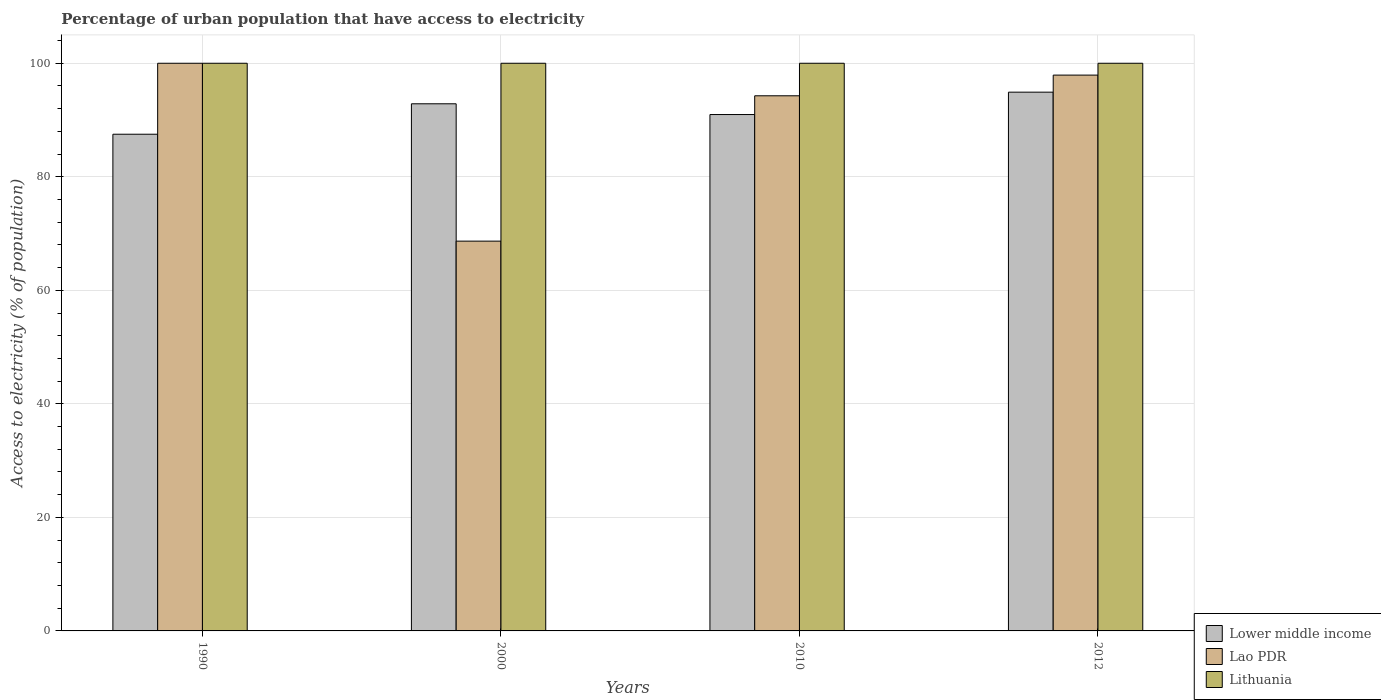How many groups of bars are there?
Offer a very short reply. 4. Are the number of bars per tick equal to the number of legend labels?
Make the answer very short. Yes. Are the number of bars on each tick of the X-axis equal?
Your answer should be compact. Yes. How many bars are there on the 3rd tick from the left?
Your answer should be compact. 3. How many bars are there on the 4th tick from the right?
Offer a terse response. 3. What is the percentage of urban population that have access to electricity in Lao PDR in 2012?
Offer a very short reply. 97.91. Across all years, what is the maximum percentage of urban population that have access to electricity in Lower middle income?
Provide a succinct answer. 94.91. Across all years, what is the minimum percentage of urban population that have access to electricity in Lao PDR?
Provide a short and direct response. 68.67. In which year was the percentage of urban population that have access to electricity in Lithuania maximum?
Offer a terse response. 1990. In which year was the percentage of urban population that have access to electricity in Lithuania minimum?
Provide a short and direct response. 1990. What is the total percentage of urban population that have access to electricity in Lao PDR in the graph?
Provide a succinct answer. 360.85. What is the difference between the percentage of urban population that have access to electricity in Lower middle income in 2000 and that in 2012?
Make the answer very short. -2.05. What is the difference between the percentage of urban population that have access to electricity in Lithuania in 2012 and the percentage of urban population that have access to electricity in Lao PDR in 1990?
Your answer should be very brief. 0. In the year 2000, what is the difference between the percentage of urban population that have access to electricity in Lao PDR and percentage of urban population that have access to electricity in Lower middle income?
Offer a terse response. -24.19. Is the percentage of urban population that have access to electricity in Lower middle income in 2000 less than that in 2010?
Offer a very short reply. No. What is the difference between the highest and the second highest percentage of urban population that have access to electricity in Lao PDR?
Provide a succinct answer. 2.09. What is the difference between the highest and the lowest percentage of urban population that have access to electricity in Lao PDR?
Your response must be concise. 31.33. Is the sum of the percentage of urban population that have access to electricity in Lithuania in 2010 and 2012 greater than the maximum percentage of urban population that have access to electricity in Lower middle income across all years?
Your answer should be compact. Yes. What does the 2nd bar from the left in 2010 represents?
Offer a terse response. Lao PDR. What does the 2nd bar from the right in 1990 represents?
Your answer should be very brief. Lao PDR. How many bars are there?
Keep it short and to the point. 12. What is the difference between two consecutive major ticks on the Y-axis?
Keep it short and to the point. 20. What is the title of the graph?
Offer a very short reply. Percentage of urban population that have access to electricity. Does "Lebanon" appear as one of the legend labels in the graph?
Offer a very short reply. No. What is the label or title of the X-axis?
Ensure brevity in your answer.  Years. What is the label or title of the Y-axis?
Ensure brevity in your answer.  Access to electricity (% of population). What is the Access to electricity (% of population) of Lower middle income in 1990?
Make the answer very short. 87.5. What is the Access to electricity (% of population) of Lao PDR in 1990?
Your answer should be very brief. 100. What is the Access to electricity (% of population) in Lower middle income in 2000?
Your answer should be compact. 92.86. What is the Access to electricity (% of population) in Lao PDR in 2000?
Give a very brief answer. 68.67. What is the Access to electricity (% of population) of Lower middle income in 2010?
Ensure brevity in your answer.  90.97. What is the Access to electricity (% of population) in Lao PDR in 2010?
Provide a short and direct response. 94.27. What is the Access to electricity (% of population) of Lower middle income in 2012?
Offer a terse response. 94.91. What is the Access to electricity (% of population) in Lao PDR in 2012?
Offer a very short reply. 97.91. What is the Access to electricity (% of population) in Lithuania in 2012?
Your answer should be very brief. 100. Across all years, what is the maximum Access to electricity (% of population) of Lower middle income?
Your answer should be very brief. 94.91. Across all years, what is the maximum Access to electricity (% of population) of Lao PDR?
Your response must be concise. 100. Across all years, what is the minimum Access to electricity (% of population) in Lower middle income?
Provide a succinct answer. 87.5. Across all years, what is the minimum Access to electricity (% of population) in Lao PDR?
Provide a short and direct response. 68.67. Across all years, what is the minimum Access to electricity (% of population) in Lithuania?
Make the answer very short. 100. What is the total Access to electricity (% of population) in Lower middle income in the graph?
Give a very brief answer. 366.23. What is the total Access to electricity (% of population) of Lao PDR in the graph?
Your answer should be very brief. 360.85. What is the total Access to electricity (% of population) of Lithuania in the graph?
Provide a succinct answer. 400. What is the difference between the Access to electricity (% of population) of Lower middle income in 1990 and that in 2000?
Provide a succinct answer. -5.36. What is the difference between the Access to electricity (% of population) in Lao PDR in 1990 and that in 2000?
Give a very brief answer. 31.33. What is the difference between the Access to electricity (% of population) in Lithuania in 1990 and that in 2000?
Your answer should be very brief. 0. What is the difference between the Access to electricity (% of population) of Lower middle income in 1990 and that in 2010?
Provide a short and direct response. -3.47. What is the difference between the Access to electricity (% of population) in Lao PDR in 1990 and that in 2010?
Your answer should be very brief. 5.73. What is the difference between the Access to electricity (% of population) of Lower middle income in 1990 and that in 2012?
Offer a very short reply. -7.41. What is the difference between the Access to electricity (% of population) in Lao PDR in 1990 and that in 2012?
Provide a succinct answer. 2.09. What is the difference between the Access to electricity (% of population) in Lithuania in 1990 and that in 2012?
Offer a very short reply. 0. What is the difference between the Access to electricity (% of population) in Lower middle income in 2000 and that in 2010?
Make the answer very short. 1.9. What is the difference between the Access to electricity (% of population) in Lao PDR in 2000 and that in 2010?
Keep it short and to the point. -25.6. What is the difference between the Access to electricity (% of population) in Lithuania in 2000 and that in 2010?
Offer a terse response. 0. What is the difference between the Access to electricity (% of population) in Lower middle income in 2000 and that in 2012?
Your answer should be compact. -2.05. What is the difference between the Access to electricity (% of population) in Lao PDR in 2000 and that in 2012?
Your answer should be compact. -29.25. What is the difference between the Access to electricity (% of population) in Lithuania in 2000 and that in 2012?
Ensure brevity in your answer.  0. What is the difference between the Access to electricity (% of population) of Lower middle income in 2010 and that in 2012?
Offer a terse response. -3.94. What is the difference between the Access to electricity (% of population) of Lao PDR in 2010 and that in 2012?
Your answer should be compact. -3.64. What is the difference between the Access to electricity (% of population) in Lower middle income in 1990 and the Access to electricity (% of population) in Lao PDR in 2000?
Provide a succinct answer. 18.83. What is the difference between the Access to electricity (% of population) of Lower middle income in 1990 and the Access to electricity (% of population) of Lithuania in 2000?
Make the answer very short. -12.5. What is the difference between the Access to electricity (% of population) of Lao PDR in 1990 and the Access to electricity (% of population) of Lithuania in 2000?
Give a very brief answer. 0. What is the difference between the Access to electricity (% of population) in Lower middle income in 1990 and the Access to electricity (% of population) in Lao PDR in 2010?
Offer a very short reply. -6.77. What is the difference between the Access to electricity (% of population) of Lower middle income in 1990 and the Access to electricity (% of population) of Lithuania in 2010?
Give a very brief answer. -12.5. What is the difference between the Access to electricity (% of population) of Lao PDR in 1990 and the Access to electricity (% of population) of Lithuania in 2010?
Offer a very short reply. 0. What is the difference between the Access to electricity (% of population) in Lower middle income in 1990 and the Access to electricity (% of population) in Lao PDR in 2012?
Provide a succinct answer. -10.42. What is the difference between the Access to electricity (% of population) of Lower middle income in 1990 and the Access to electricity (% of population) of Lithuania in 2012?
Make the answer very short. -12.5. What is the difference between the Access to electricity (% of population) in Lower middle income in 2000 and the Access to electricity (% of population) in Lao PDR in 2010?
Provide a short and direct response. -1.41. What is the difference between the Access to electricity (% of population) of Lower middle income in 2000 and the Access to electricity (% of population) of Lithuania in 2010?
Ensure brevity in your answer.  -7.14. What is the difference between the Access to electricity (% of population) of Lao PDR in 2000 and the Access to electricity (% of population) of Lithuania in 2010?
Your answer should be very brief. -31.33. What is the difference between the Access to electricity (% of population) in Lower middle income in 2000 and the Access to electricity (% of population) in Lao PDR in 2012?
Provide a short and direct response. -5.05. What is the difference between the Access to electricity (% of population) of Lower middle income in 2000 and the Access to electricity (% of population) of Lithuania in 2012?
Offer a very short reply. -7.14. What is the difference between the Access to electricity (% of population) in Lao PDR in 2000 and the Access to electricity (% of population) in Lithuania in 2012?
Keep it short and to the point. -31.33. What is the difference between the Access to electricity (% of population) of Lower middle income in 2010 and the Access to electricity (% of population) of Lao PDR in 2012?
Keep it short and to the point. -6.95. What is the difference between the Access to electricity (% of population) of Lower middle income in 2010 and the Access to electricity (% of population) of Lithuania in 2012?
Offer a terse response. -9.03. What is the difference between the Access to electricity (% of population) in Lao PDR in 2010 and the Access to electricity (% of population) in Lithuania in 2012?
Give a very brief answer. -5.73. What is the average Access to electricity (% of population) of Lower middle income per year?
Provide a short and direct response. 91.56. What is the average Access to electricity (% of population) in Lao PDR per year?
Make the answer very short. 90.21. What is the average Access to electricity (% of population) in Lithuania per year?
Your answer should be very brief. 100. In the year 1990, what is the difference between the Access to electricity (% of population) in Lower middle income and Access to electricity (% of population) in Lao PDR?
Ensure brevity in your answer.  -12.5. In the year 1990, what is the difference between the Access to electricity (% of population) in Lower middle income and Access to electricity (% of population) in Lithuania?
Your response must be concise. -12.5. In the year 1990, what is the difference between the Access to electricity (% of population) in Lao PDR and Access to electricity (% of population) in Lithuania?
Give a very brief answer. 0. In the year 2000, what is the difference between the Access to electricity (% of population) in Lower middle income and Access to electricity (% of population) in Lao PDR?
Your answer should be very brief. 24.19. In the year 2000, what is the difference between the Access to electricity (% of population) of Lower middle income and Access to electricity (% of population) of Lithuania?
Your response must be concise. -7.14. In the year 2000, what is the difference between the Access to electricity (% of population) of Lao PDR and Access to electricity (% of population) of Lithuania?
Ensure brevity in your answer.  -31.33. In the year 2010, what is the difference between the Access to electricity (% of population) of Lower middle income and Access to electricity (% of population) of Lao PDR?
Offer a terse response. -3.3. In the year 2010, what is the difference between the Access to electricity (% of population) in Lower middle income and Access to electricity (% of population) in Lithuania?
Provide a succinct answer. -9.03. In the year 2010, what is the difference between the Access to electricity (% of population) of Lao PDR and Access to electricity (% of population) of Lithuania?
Provide a succinct answer. -5.73. In the year 2012, what is the difference between the Access to electricity (% of population) of Lower middle income and Access to electricity (% of population) of Lao PDR?
Ensure brevity in your answer.  -3.01. In the year 2012, what is the difference between the Access to electricity (% of population) of Lower middle income and Access to electricity (% of population) of Lithuania?
Provide a short and direct response. -5.09. In the year 2012, what is the difference between the Access to electricity (% of population) of Lao PDR and Access to electricity (% of population) of Lithuania?
Your answer should be compact. -2.09. What is the ratio of the Access to electricity (% of population) in Lower middle income in 1990 to that in 2000?
Provide a succinct answer. 0.94. What is the ratio of the Access to electricity (% of population) of Lao PDR in 1990 to that in 2000?
Keep it short and to the point. 1.46. What is the ratio of the Access to electricity (% of population) in Lower middle income in 1990 to that in 2010?
Your answer should be compact. 0.96. What is the ratio of the Access to electricity (% of population) of Lao PDR in 1990 to that in 2010?
Your answer should be very brief. 1.06. What is the ratio of the Access to electricity (% of population) of Lower middle income in 1990 to that in 2012?
Give a very brief answer. 0.92. What is the ratio of the Access to electricity (% of population) in Lao PDR in 1990 to that in 2012?
Ensure brevity in your answer.  1.02. What is the ratio of the Access to electricity (% of population) of Lower middle income in 2000 to that in 2010?
Ensure brevity in your answer.  1.02. What is the ratio of the Access to electricity (% of population) of Lao PDR in 2000 to that in 2010?
Make the answer very short. 0.73. What is the ratio of the Access to electricity (% of population) in Lower middle income in 2000 to that in 2012?
Your answer should be very brief. 0.98. What is the ratio of the Access to electricity (% of population) in Lao PDR in 2000 to that in 2012?
Offer a terse response. 0.7. What is the ratio of the Access to electricity (% of population) of Lower middle income in 2010 to that in 2012?
Offer a terse response. 0.96. What is the ratio of the Access to electricity (% of population) in Lao PDR in 2010 to that in 2012?
Keep it short and to the point. 0.96. What is the difference between the highest and the second highest Access to electricity (% of population) of Lower middle income?
Your answer should be compact. 2.05. What is the difference between the highest and the second highest Access to electricity (% of population) of Lao PDR?
Provide a short and direct response. 2.09. What is the difference between the highest and the lowest Access to electricity (% of population) in Lower middle income?
Offer a very short reply. 7.41. What is the difference between the highest and the lowest Access to electricity (% of population) of Lao PDR?
Give a very brief answer. 31.33. What is the difference between the highest and the lowest Access to electricity (% of population) of Lithuania?
Keep it short and to the point. 0. 